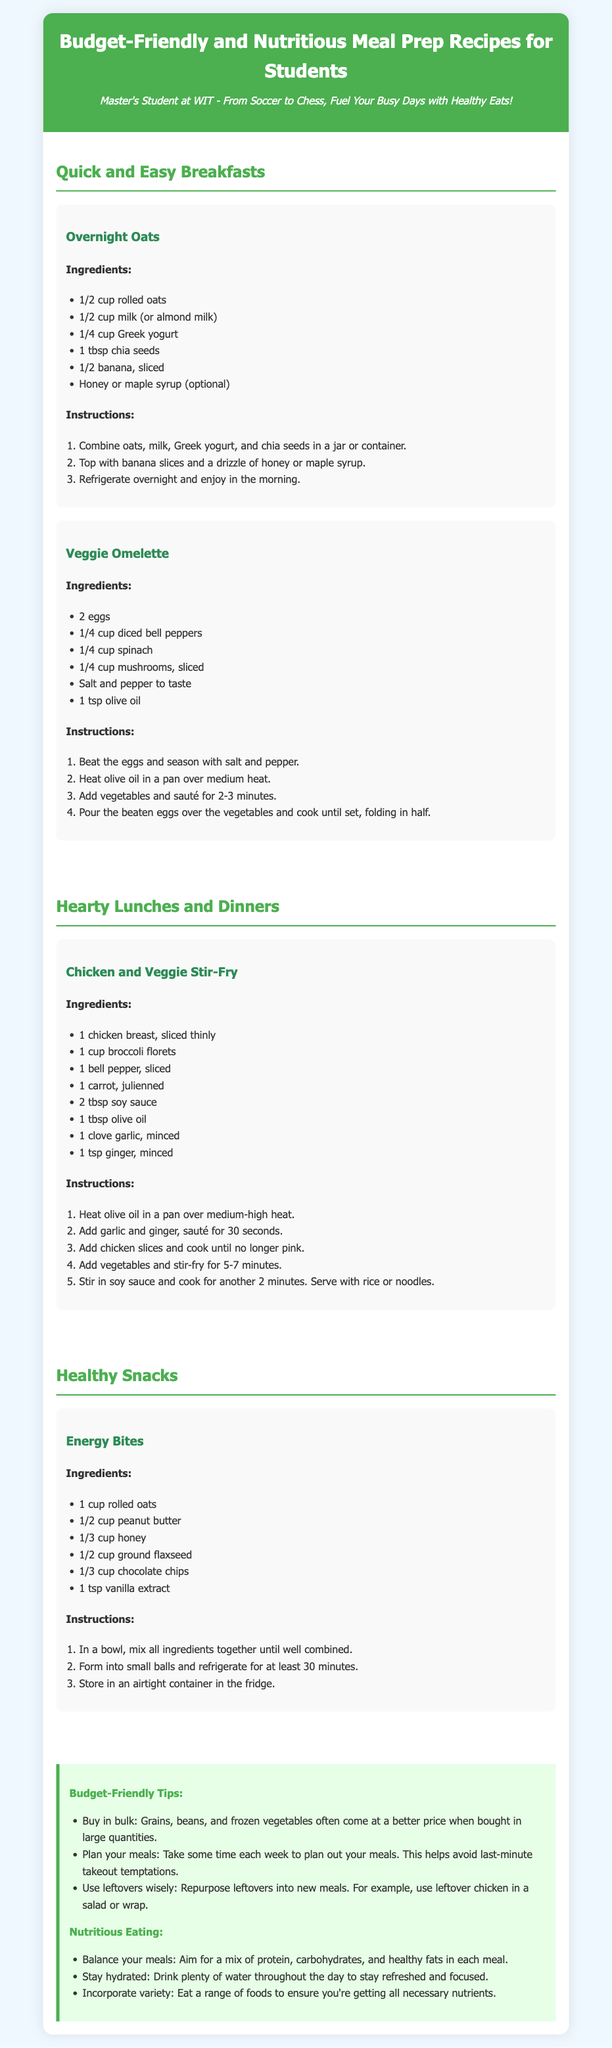what is the first breakfast recipe? The first breakfast recipe listed in the document is "Overnight Oats."
Answer: Overnight Oats how many ingredients are needed for the Veggie Omelette? The Veggie Omelette recipe requires 6 ingredients as listed.
Answer: 6 what type of snacks are featured in the document? The document features "Healthy Snacks" which includes "Energy Bites."
Answer: Energy Bites how long should Energy Bites be refrigerated? The Energy Bites should be refrigerated for at least 30 minutes before serving.
Answer: 30 minutes what protein source is used in the Chicken and Veggie Stir-Fry? The protein source used in the Chicken and Veggie Stir-Fry is "chicken breast."
Answer: chicken breast what is recommended to stay hydrated? The document recommends to "drink plenty of water" to stay hydrated throughout the day.
Answer: drink plenty of water how many tips are provided for budget-friendly eating? There are 3 tips listed under "Budget-Friendly Tips" in the document.
Answer: 3 which meal type is the Veggie Omelette categorized under? The Veggie Omelette is categorized under "Quick and Easy Breakfasts."
Answer: Quick and Easy Breakfasts what does the recipe for Chicken and Veggie Stir-Fry serve with? The Chicken and Veggie Stir-Fry serves with "rice or noodles."
Answer: rice or noodles 